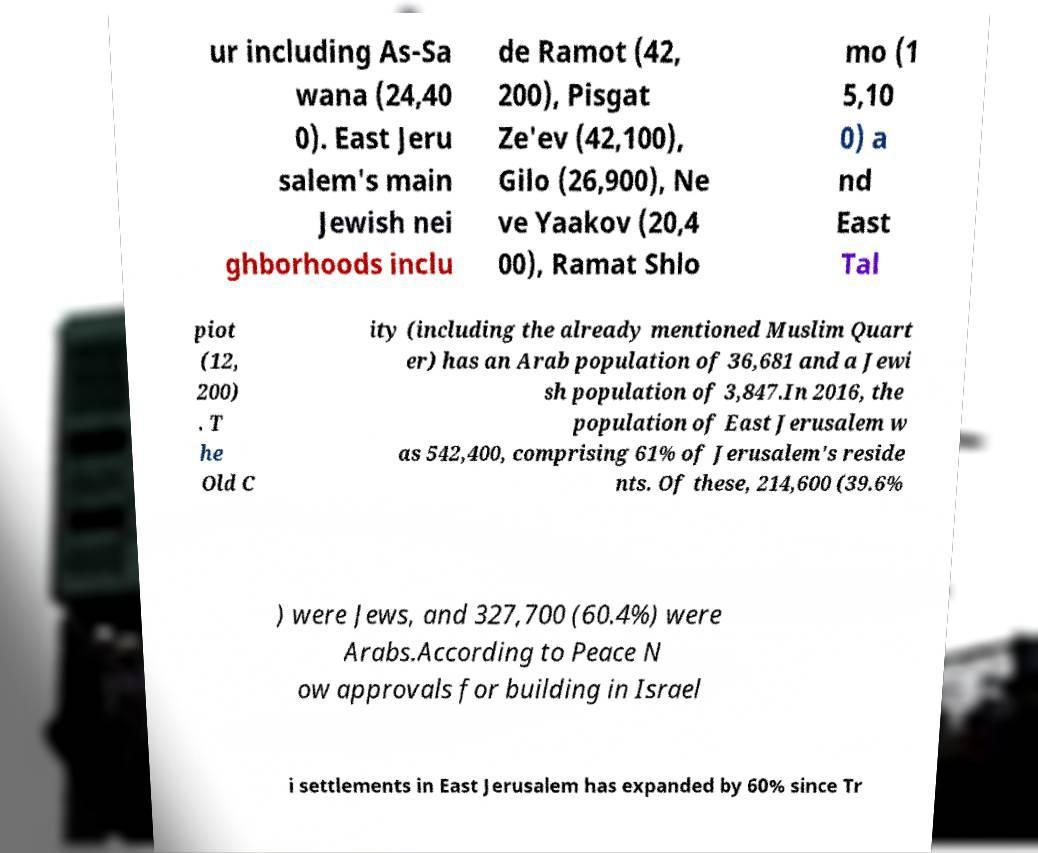There's text embedded in this image that I need extracted. Can you transcribe it verbatim? ur including As-Sa wana (24,40 0). East Jeru salem's main Jewish nei ghborhoods inclu de Ramot (42, 200), Pisgat Ze'ev (42,100), Gilo (26,900), Ne ve Yaakov (20,4 00), Ramat Shlo mo (1 5,10 0) a nd East Tal piot (12, 200) . T he Old C ity (including the already mentioned Muslim Quart er) has an Arab population of 36,681 and a Jewi sh population of 3,847.In 2016, the population of East Jerusalem w as 542,400, comprising 61% of Jerusalem's reside nts. Of these, 214,600 (39.6% ) were Jews, and 327,700 (60.4%) were Arabs.According to Peace N ow approvals for building in Israel i settlements in East Jerusalem has expanded by 60% since Tr 